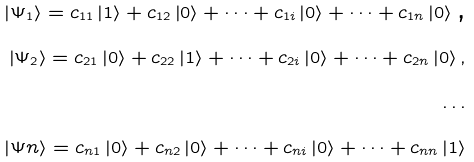<formula> <loc_0><loc_0><loc_500><loc_500>\left | \Psi _ { 1 } \right \rangle = c _ { 1 1 } \left | 1 \right \rangle + c _ { 1 2 } \left | 0 \right \rangle + \dots + c _ { 1 i } \left | 0 \right \rangle + \dots + c _ { 1 n } \left | 0 \right \rangle \text {,} \\ \left | \Psi _ { 2 } \right \rangle = c _ { 2 1 } \left | 0 \right \rangle + c _ { 2 2 } \left | 1 \right \rangle + \dots + c _ { 2 i } \left | 0 \right \rangle + \dots + c _ { 2 n } \left | 0 \right \rangle \text {,} \\ \dots \\ \left | \Psi n \right \rangle = c _ { n 1 } \left | 0 \right \rangle + c _ { n 2 } \left | 0 \right \rangle + \dots + c _ { n i } \left | 0 \right \rangle + \dots + c _ { n n } \left | 1 \right \rangle</formula> 